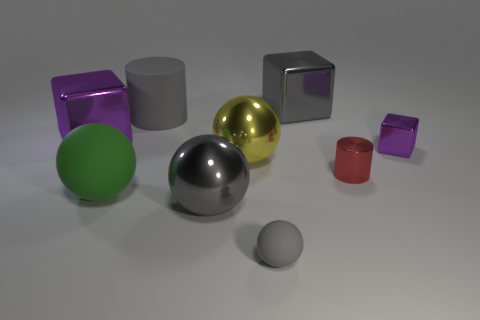Subtract 1 spheres. How many spheres are left? 3 Add 1 big green spheres. How many objects exist? 10 Subtract all cylinders. How many objects are left? 7 Add 9 small gray balls. How many small gray balls are left? 10 Add 2 large rubber spheres. How many large rubber spheres exist? 3 Subtract 0 cyan cylinders. How many objects are left? 9 Subtract all big purple shiny blocks. Subtract all tiny rubber spheres. How many objects are left? 7 